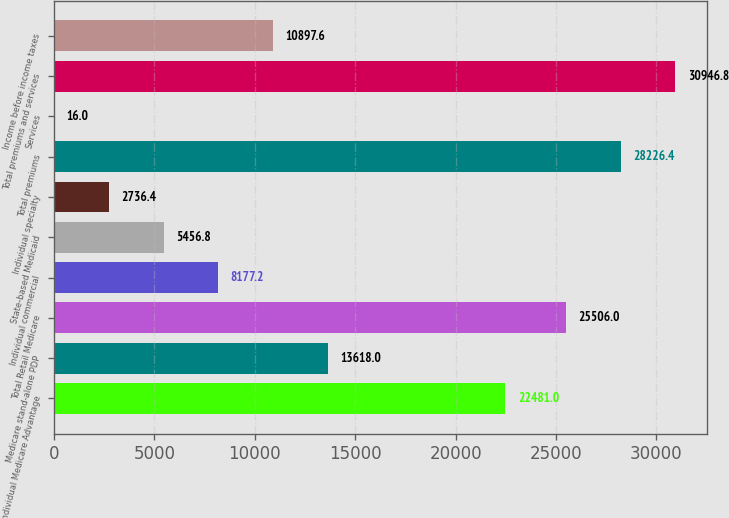Convert chart. <chart><loc_0><loc_0><loc_500><loc_500><bar_chart><fcel>Individual Medicare Advantage<fcel>Medicare stand-alone PDP<fcel>Total Retail Medicare<fcel>Individual commercial<fcel>State-based Medicaid<fcel>Individual specialty<fcel>Total premiums<fcel>Services<fcel>Total premiums and services<fcel>Income before income taxes<nl><fcel>22481<fcel>13618<fcel>25506<fcel>8177.2<fcel>5456.8<fcel>2736.4<fcel>28226.4<fcel>16<fcel>30946.8<fcel>10897.6<nl></chart> 